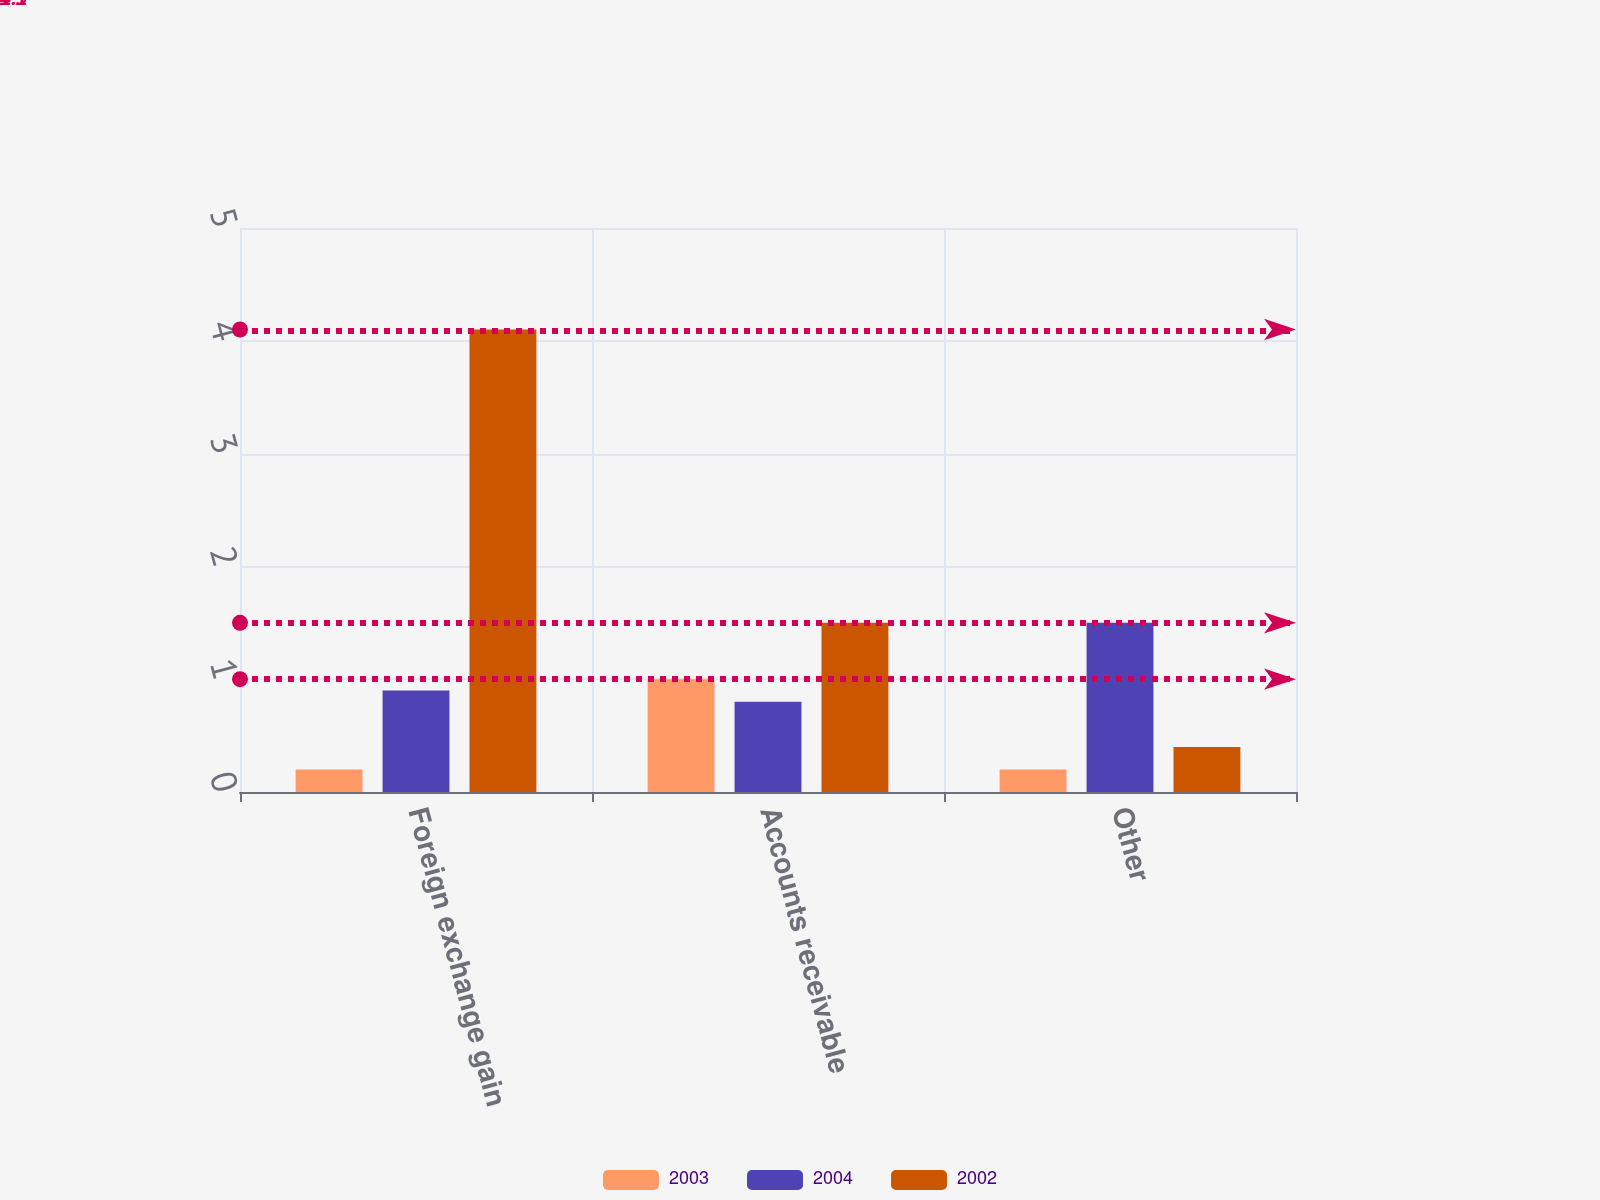Convert chart to OTSL. <chart><loc_0><loc_0><loc_500><loc_500><stacked_bar_chart><ecel><fcel>Foreign exchange gain<fcel>Accounts receivable<fcel>Other<nl><fcel>2003<fcel>0.2<fcel>1<fcel>0.2<nl><fcel>2004<fcel>0.9<fcel>0.8<fcel>1.5<nl><fcel>2002<fcel>4.1<fcel>1.5<fcel>0.4<nl></chart> 